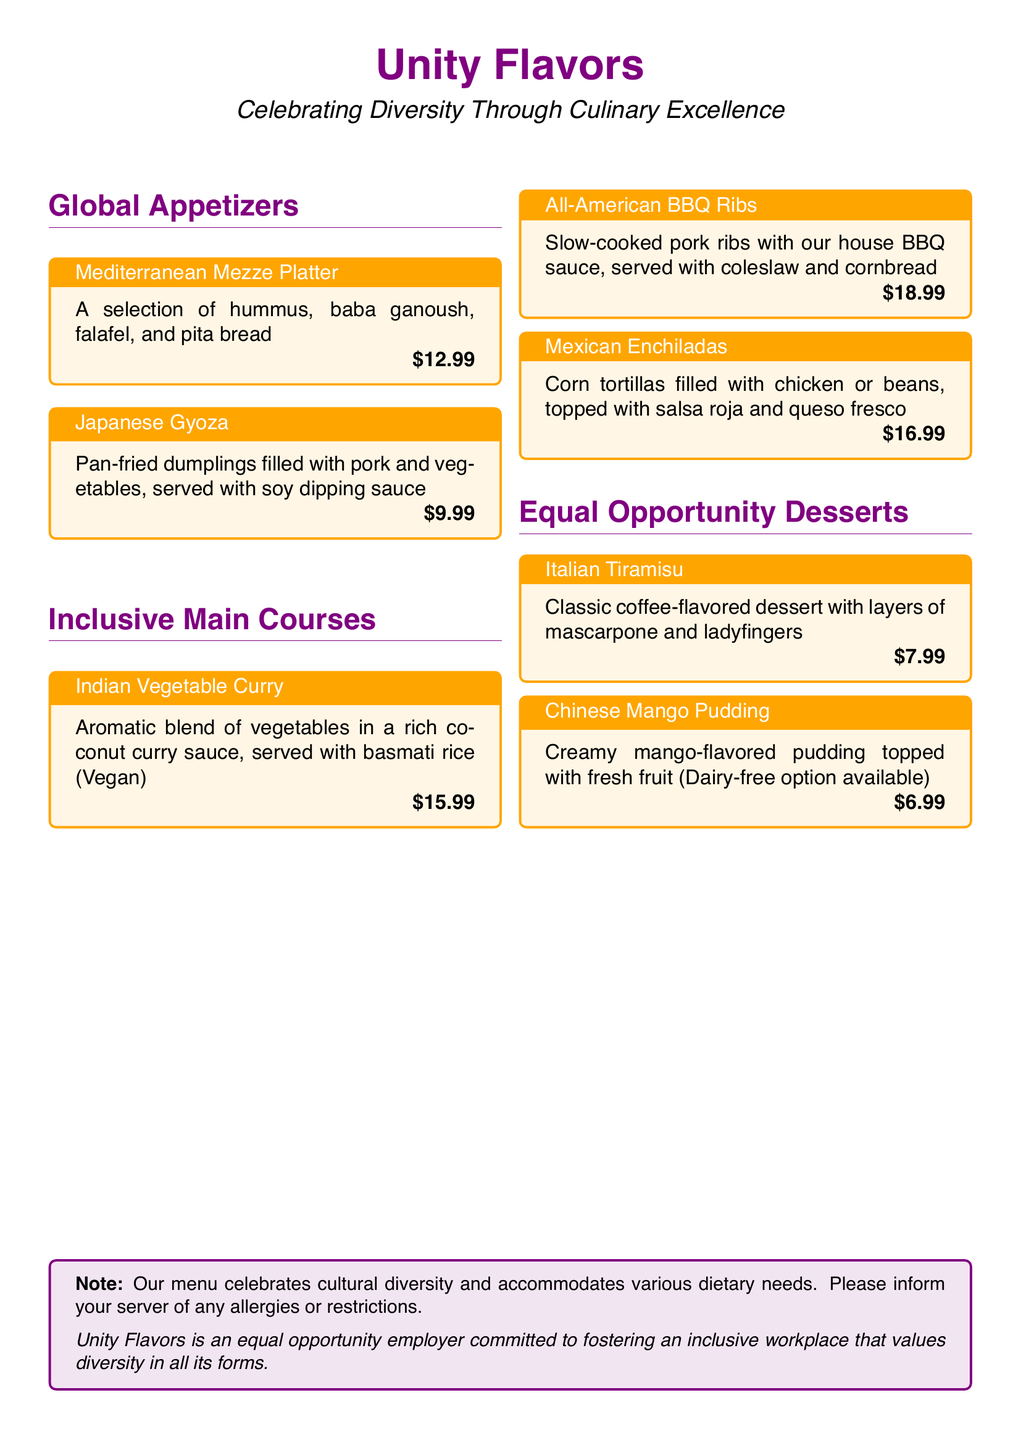What is the name of the restaurant? The name of the restaurant, as indicated in the menu, is "Unity Flavors."
Answer: Unity Flavors What is the price of the Mediterranean Mezze Platter? The price listed for the Mediterranean Mezze Platter is shown directly beneath its description.
Answer: $12.99 Which dish is vegan? The dish labeled as vegan can be identified in the main courses section, specifically in the description.
Answer: Indian Vegetable Curry What type of sauce accompanies the Japanese Gyoza? The type of sauce served with Japanese Gyoza is mentioned in the description of the dish.
Answer: Soy dipping sauce How many dessert options are listed on the menu? To find the number of dessert options, count the dessert items listed in the document.
Answer: 2 Which dessert has a dairy-free option available? The dessert that offers a dairy-free option is explicitly indicated in its description.
Answer: Chinese Mango Pudding What is the theme of Unity Flavors' menu? The theme of the menu can be summarized by the phrase provided at the beginning of the document.
Answer: Celebrating Diversity Through Culinary Excellence Does the menu mention dietary accommodations? The note at the bottom suggests that the menu includes information on dietary accommodations.
Answer: Yes What color is used for the title headings? The document specifies the color used for the title headings in the formatting section.
Answer: Unity purple 